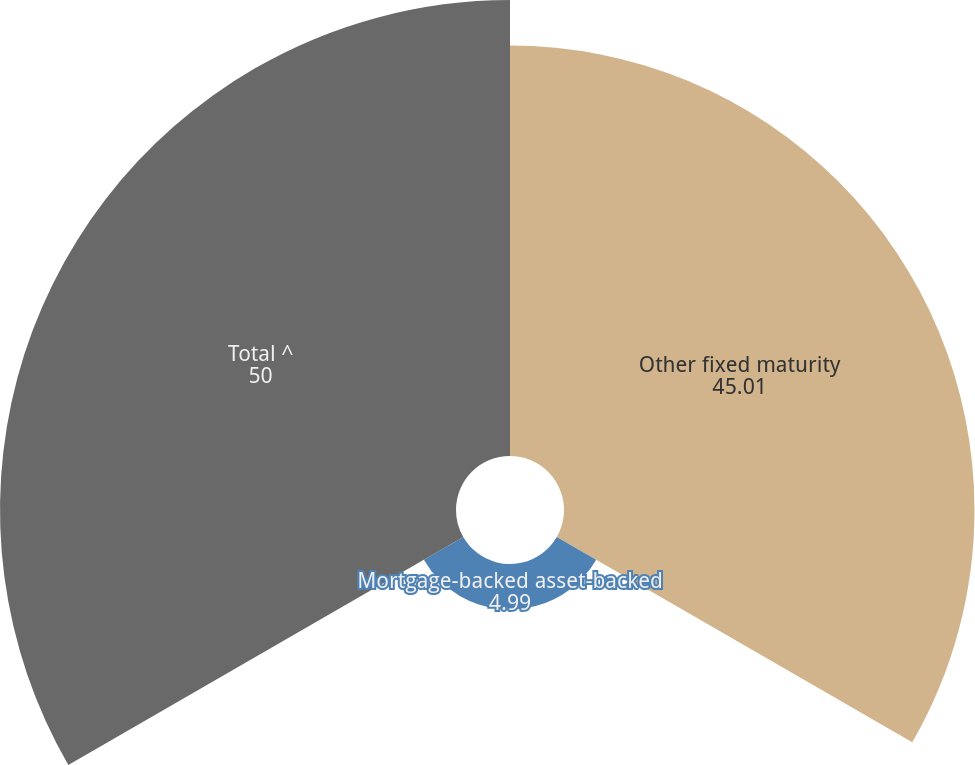<chart> <loc_0><loc_0><loc_500><loc_500><pie_chart><fcel>Other fixed maturity<fcel>Mortgage-backed asset-backed<fcel>Total ^<nl><fcel>45.01%<fcel>4.99%<fcel>50.0%<nl></chart> 